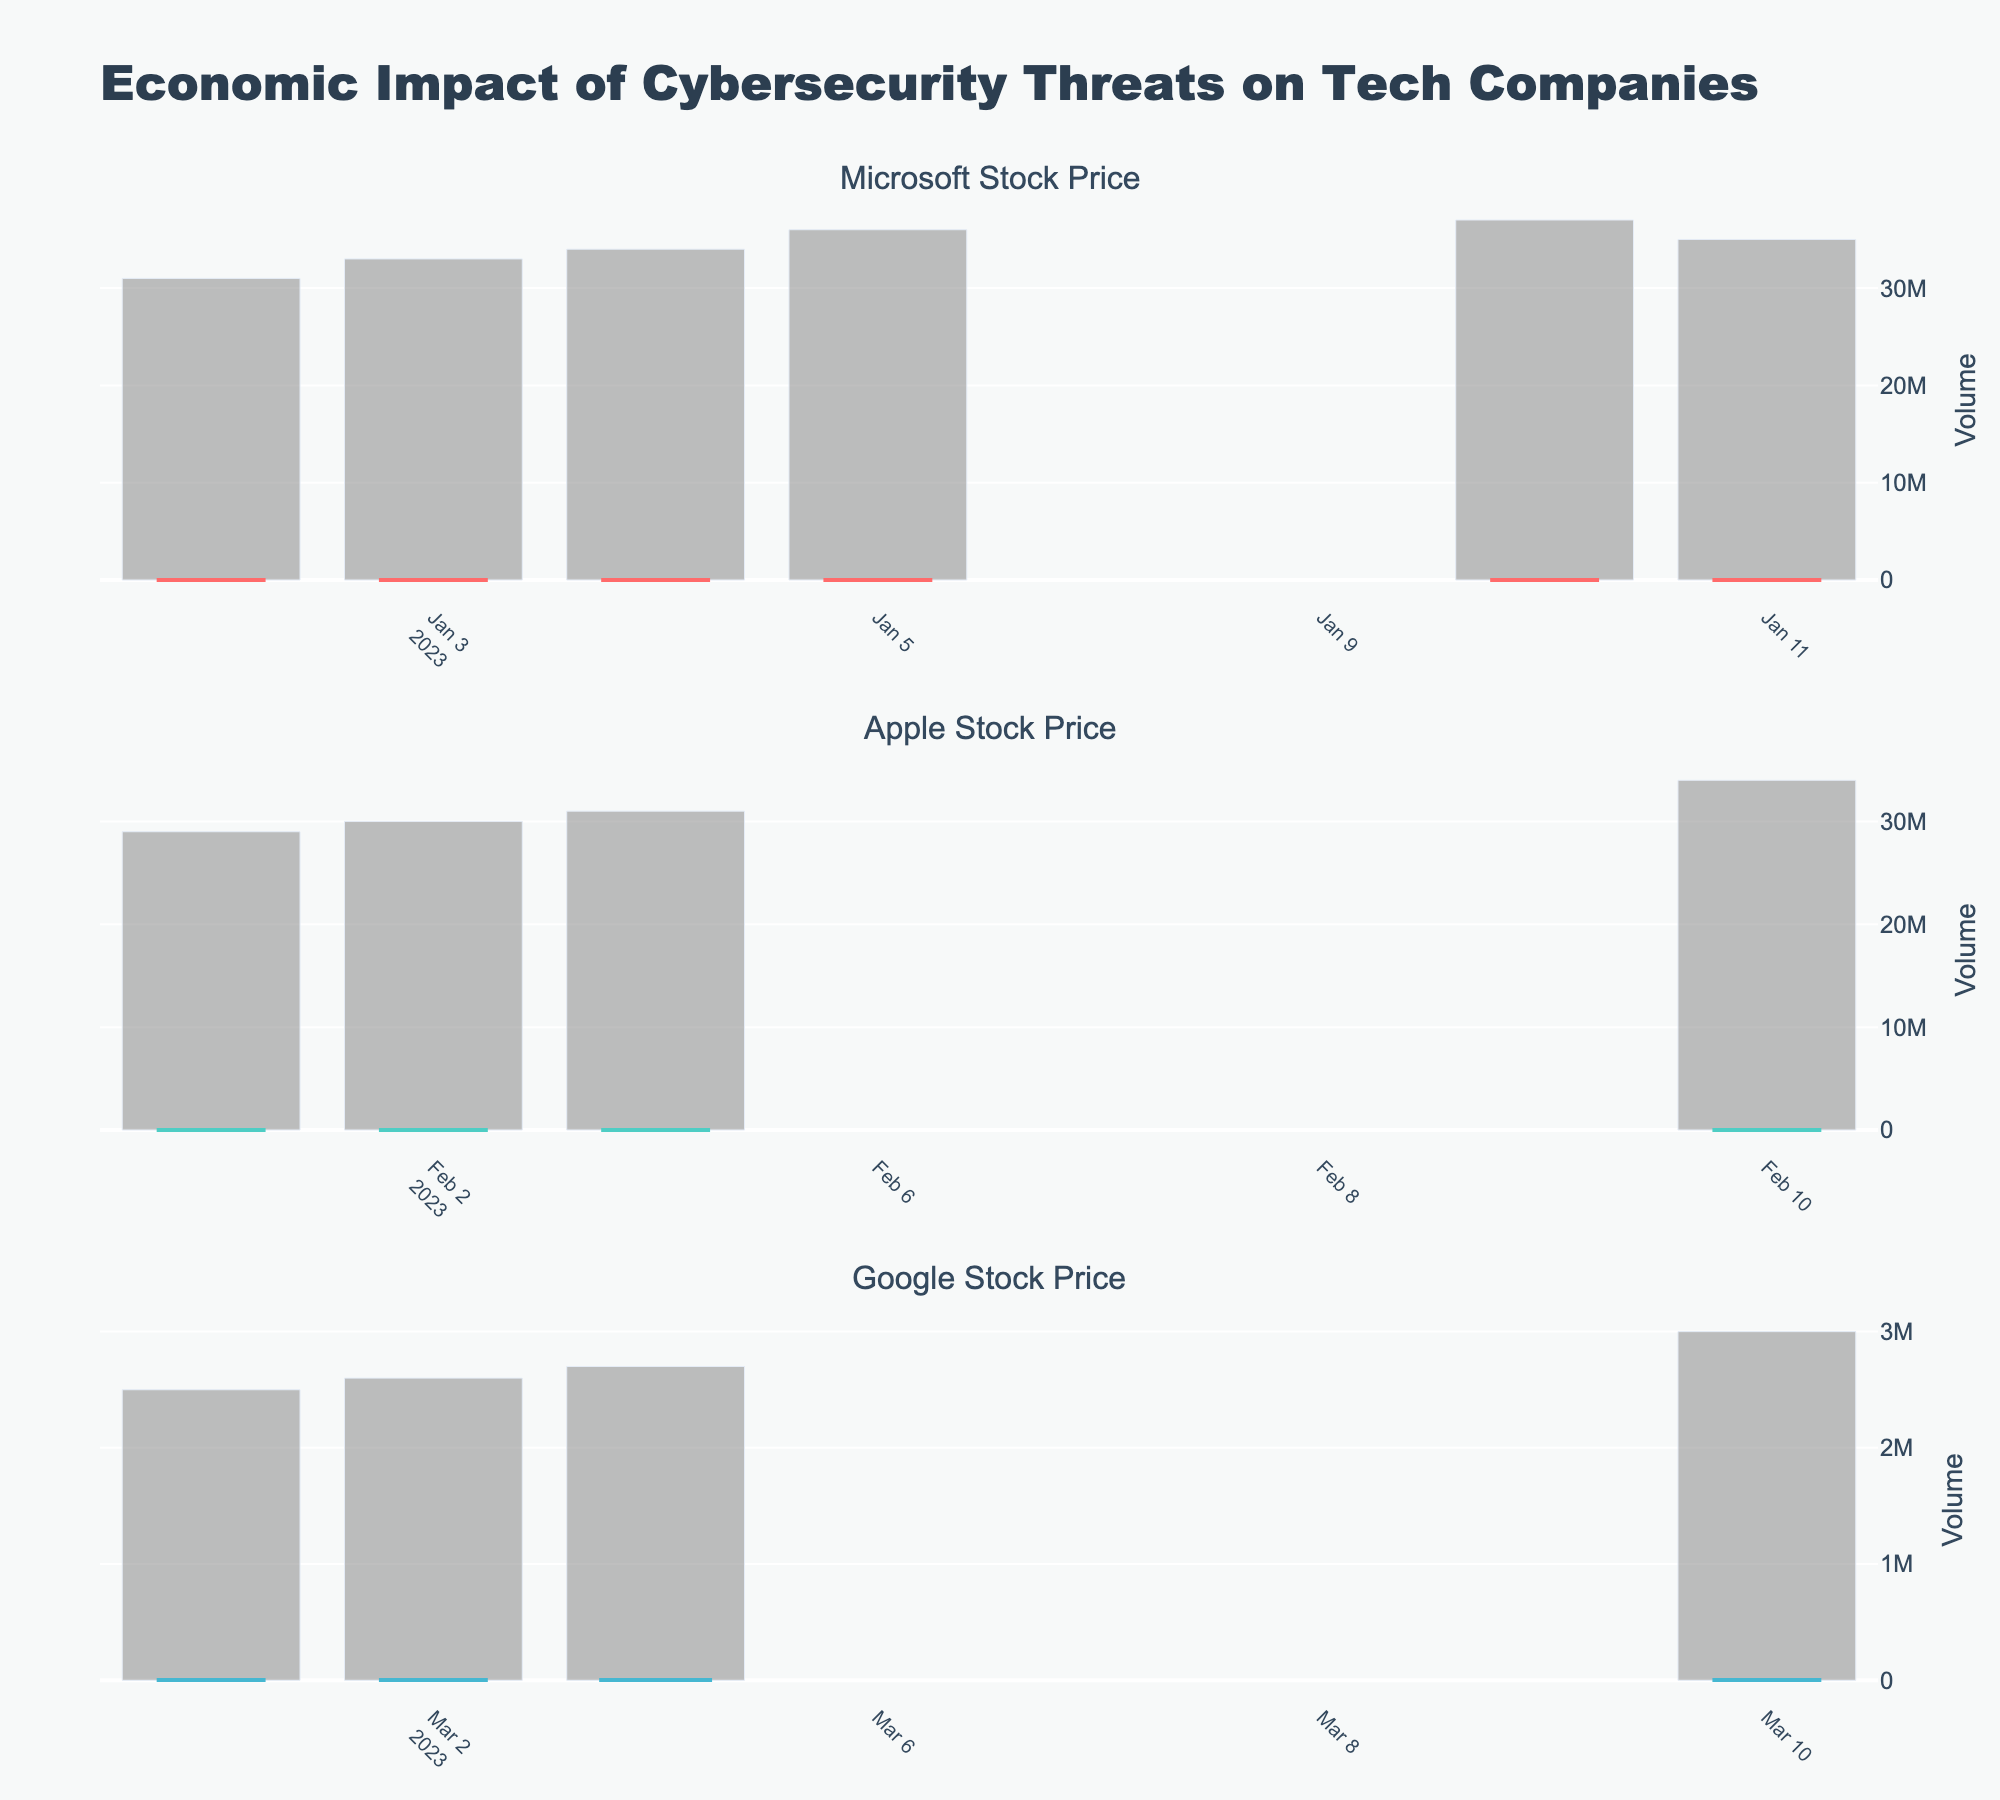How many companies are analyzed in the stock price figure? The figure contains separate plots for each company. The title of each subplot provides the company's name. By counting these titles, it is evident how many companies are present.
Answer: 3 What is the closing price of Microsoft on January 5, 2023? Look at the candlestick plot for Microsoft. Locate January 5, 2023, on the x-axis and identify the closing price on that date.
Answer: 245.00 Which company had the highest closing price during the given period? Observe each company's candlestick plot and identify the highest closing price by examining the top points of the candlesticks. Compare these highest closing prices across all companies.
Answer: Google Compare the trading volumes of Microsoft and Apple on the dates January 10, 2023, and February 10, 2023, respectively. Which company had a higher volume? Check the volume bar charts, which accompany the candlestick plots. For the specific dates, find the height of each bar representing the volume and compare them.
Answer: Microsoft By how much did Apple's closing price increase from February 1, 2023, to February 11, 2023? Look at Apple's candlestick plot to get the closing prices on February 1 and February 11. Subtract the closing price on February 1 from that on February 11.
Answer: 15 On which date did Google's stock price close highest after opening at $2950.00 or above? Examine Google's candlestick plot. Identify the dates where the opening price was at least $2950.00 and then find the date with the highest closing price on those dates.
Answer: March 11, 2023 What was the average closing price of Microsoft between January 1, 2023, and January 11, 2023? Look at all the closing prices of Microsoft within this range, sum them up, and divide by the number of closing prices (which is 7).
Answer: 243.36 Which company experienced the largest increase in stock price from the opening to the closing price on a single day? For each candlestick plot, find the day with the largest difference between the opening and closing prices, then compare these differences across companies.
Answer: Google Is there a noticeable trend in the volume traded for any of the companies over the given dates? Check the volume bar charts for each company. Look for patterns where the volume consistently increases, decreases, or remains stable over time.
Answer: Yes, increasing volume What anomaly, if any, can be observed in Apple's stock price movements compared to Microsoft and Google? Compare the candlestick plots of Apple, Microsoft, and Google. Look for any unusual price movements, such as sudden spikes or falls, that are not observed in the other companies.
Answer: Steady increase 